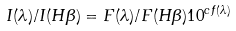<formula> <loc_0><loc_0><loc_500><loc_500>I ( \lambda ) / I ( H \beta ) = F ( \lambda ) / F ( H \beta ) 1 0 ^ { c f ( \lambda ) }</formula> 